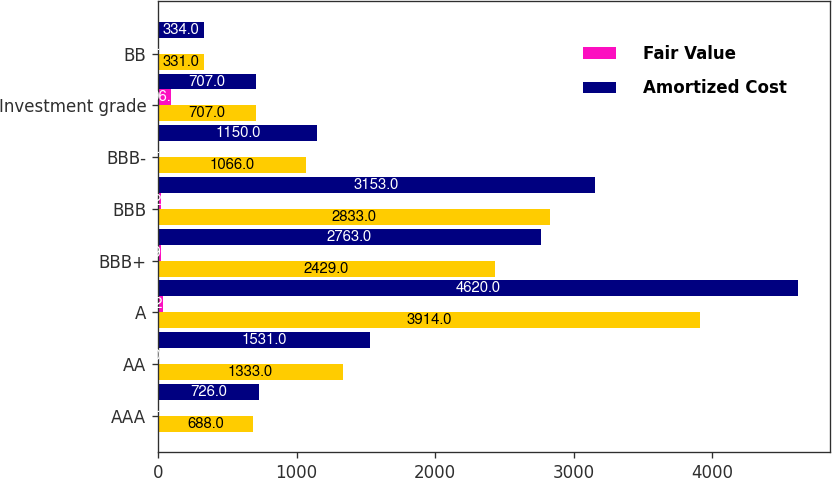<chart> <loc_0><loc_0><loc_500><loc_500><stacked_bar_chart><ecel><fcel>AAA<fcel>AA<fcel>A<fcel>BBB+<fcel>BBB<fcel>BBB-<fcel>Investment grade<fcel>BB<nl><fcel>nan<fcel>688<fcel>1333<fcel>3914<fcel>2429<fcel>2833<fcel>1066<fcel>707<fcel>331<nl><fcel>Fair Value<fcel>5<fcel>10<fcel>32<fcel>19<fcel>22<fcel>8<fcel>96<fcel>2<nl><fcel>Amortized Cost<fcel>726<fcel>1531<fcel>4620<fcel>2763<fcel>3153<fcel>1150<fcel>707<fcel>334<nl></chart> 